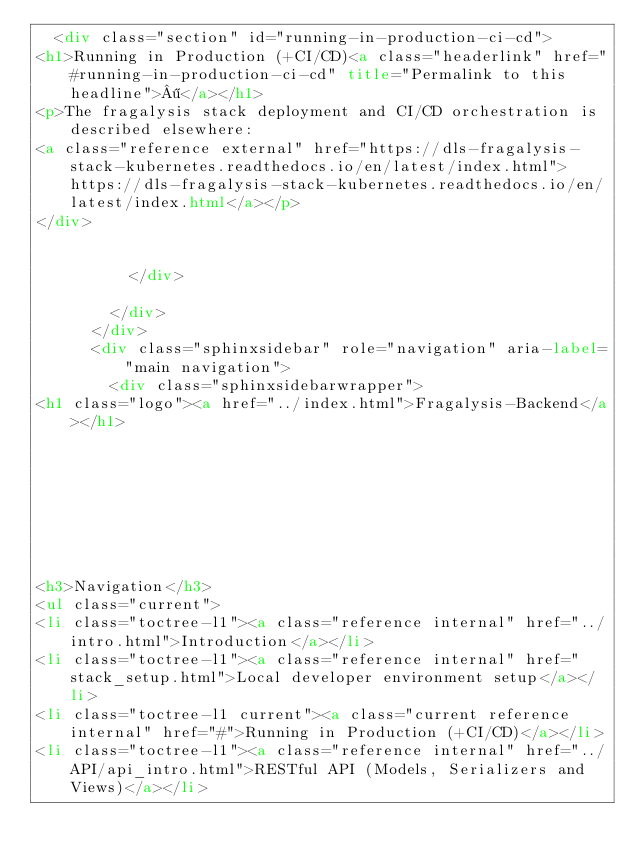Convert code to text. <code><loc_0><loc_0><loc_500><loc_500><_HTML_>  <div class="section" id="running-in-production-ci-cd">
<h1>Running in Production (+CI/CD)<a class="headerlink" href="#running-in-production-ci-cd" title="Permalink to this headline">¶</a></h1>
<p>The fragalysis stack deployment and CI/CD orchestration is described elsewhere:
<a class="reference external" href="https://dls-fragalysis-stack-kubernetes.readthedocs.io/en/latest/index.html">https://dls-fragalysis-stack-kubernetes.readthedocs.io/en/latest/index.html</a></p>
</div>


          </div>
          
        </div>
      </div>
      <div class="sphinxsidebar" role="navigation" aria-label="main navigation">
        <div class="sphinxsidebarwrapper">
<h1 class="logo"><a href="../index.html">Fragalysis-Backend</a></h1>








<h3>Navigation</h3>
<ul class="current">
<li class="toctree-l1"><a class="reference internal" href="../intro.html">Introduction</a></li>
<li class="toctree-l1"><a class="reference internal" href="stack_setup.html">Local developer environment setup</a></li>
<li class="toctree-l1 current"><a class="current reference internal" href="#">Running in Production (+CI/CD)</a></li>
<li class="toctree-l1"><a class="reference internal" href="../API/api_intro.html">RESTful API (Models, Serializers and Views)</a></li></code> 